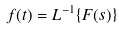Convert formula to latex. <formula><loc_0><loc_0><loc_500><loc_500>f ( t ) = L ^ { - 1 } \{ F ( s ) \}</formula> 